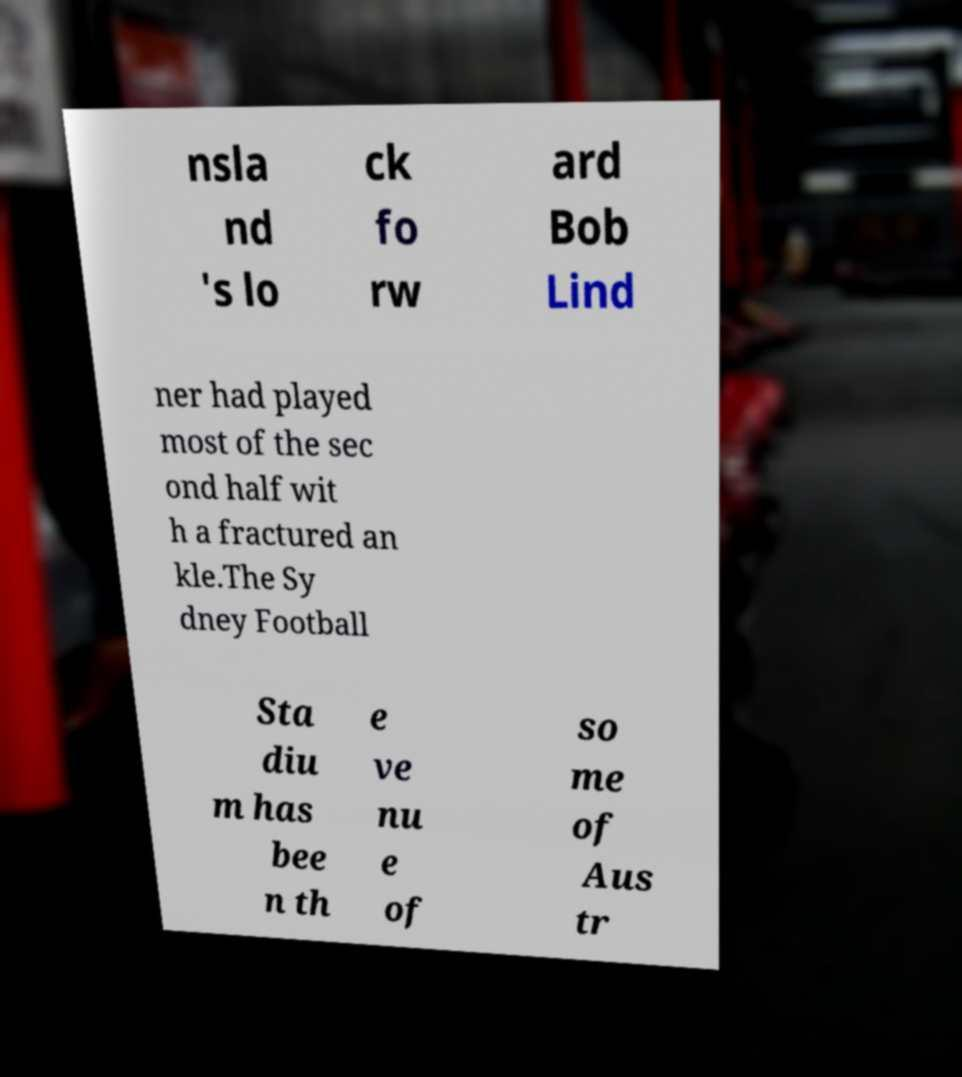There's text embedded in this image that I need extracted. Can you transcribe it verbatim? nsla nd 's lo ck fo rw ard Bob Lind ner had played most of the sec ond half wit h a fractured an kle.The Sy dney Football Sta diu m has bee n th e ve nu e of so me of Aus tr 